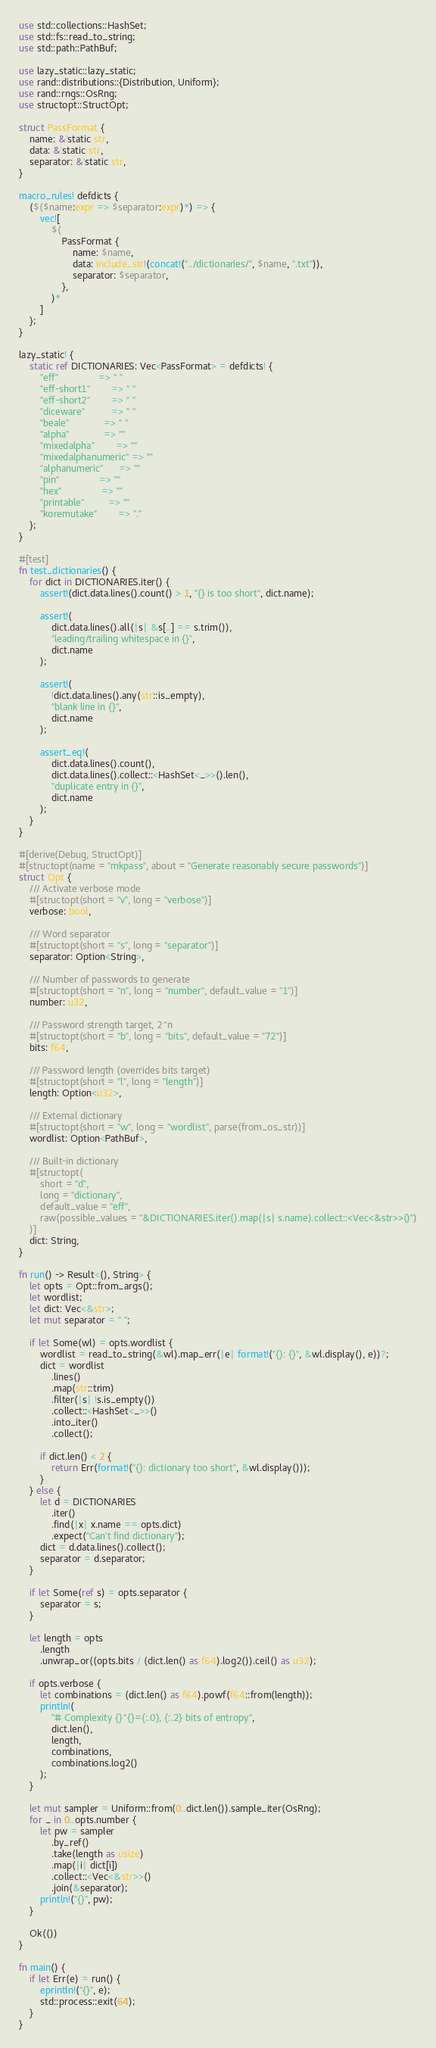<code> <loc_0><loc_0><loc_500><loc_500><_Rust_>use std::collections::HashSet;
use std::fs::read_to_string;
use std::path::PathBuf;

use lazy_static::lazy_static;
use rand::distributions::{Distribution, Uniform};
use rand::rngs::OsRng;
use structopt::StructOpt;

struct PassFormat {
    name: &'static str,
    data: &'static str,
    separator: &'static str,
}

macro_rules! defdicts {
    ($($name:expr => $separator:expr)*) => {
        vec![
            $(
                PassFormat {
                    name: $name,
                    data: include_str!(concat!("../dictionaries/", $name, ".txt")),
                    separator: $separator,
                },
            )*
        ]
    };
}

lazy_static! {
    static ref DICTIONARIES: Vec<PassFormat> = defdicts! {
        "eff"               => " "
        "eff-short1"        => " "
        "eff-short2"        => " "
        "diceware"          => " "
        "beale"             => " "
        "alpha"             => ""
        "mixedalpha"        => ""
        "mixedalphanumeric" => ""
        "alphanumeric"      => ""
        "pin"               => ""
        "hex"               => ""
        "printable"         => ""
        "koremutake"        => "."
    };
}

#[test]
fn test_dictionaries() {
    for dict in DICTIONARIES.iter() {
        assert!(dict.data.lines().count() > 1, "{} is too short", dict.name);

        assert!(
            dict.data.lines().all(|s| &s[..] == s.trim()),
            "leading/trailing whitespace in {}",
            dict.name
        );

        assert!(
            !dict.data.lines().any(str::is_empty),
            "blank line in {}",
            dict.name
        );

        assert_eq!(
            dict.data.lines().count(),
            dict.data.lines().collect::<HashSet<_>>().len(),
            "duplicate entry in {}",
            dict.name
        );
    }
}

#[derive(Debug, StructOpt)]
#[structopt(name = "mkpass", about = "Generate reasonably secure passwords")]
struct Opt {
    /// Activate verbose mode
    #[structopt(short = "v", long = "verbose")]
    verbose: bool,

    /// Word separator
    #[structopt(short = "s", long = "separator")]
    separator: Option<String>,

    /// Number of passwords to generate
    #[structopt(short = "n", long = "number", default_value = "1")]
    number: u32,

    /// Password strength target, 2^n
    #[structopt(short = "b", long = "bits", default_value = "72")]
    bits: f64,

    /// Password length (overrides bits target)
    #[structopt(short = "l", long = "length")]
    length: Option<u32>,

    /// External dictionary
    #[structopt(short = "w", long = "wordlist", parse(from_os_str))]
    wordlist: Option<PathBuf>,

    /// Built-in dictionary
    #[structopt(
        short = "d",
        long = "dictionary",
        default_value = "eff",
        raw(possible_values = "&DICTIONARIES.iter().map(|s| s.name).collect::<Vec<&str>>()")
    )]
    dict: String,
}

fn run() -> Result<(), String> {
    let opts = Opt::from_args();
    let wordlist;
    let dict: Vec<&str>;
    let mut separator = " ";

    if let Some(wl) = opts.wordlist {
        wordlist = read_to_string(&wl).map_err(|e| format!("{}: {}", &wl.display(), e))?;
        dict = wordlist
            .lines()
            .map(str::trim)
            .filter(|s| !s.is_empty())
            .collect::<HashSet<_>>()
            .into_iter()
            .collect();

        if dict.len() < 2 {
            return Err(format!("{}: dictionary too short", &wl.display()));
        }
    } else {
        let d = DICTIONARIES
            .iter()
            .find(|x| x.name == opts.dict)
            .expect("Can't find dictionary");
        dict = d.data.lines().collect();
        separator = d.separator;
    }

    if let Some(ref s) = opts.separator {
        separator = s;
    }

    let length = opts
        .length
        .unwrap_or((opts.bits / (dict.len() as f64).log2()).ceil() as u32);

    if opts.verbose {
        let combinations = (dict.len() as f64).powf(f64::from(length));
        println!(
            "# Complexity {}^{}={:.0}, {:.2} bits of entropy",
            dict.len(),
            length,
            combinations,
            combinations.log2()
        );
    }

    let mut sampler = Uniform::from(0..dict.len()).sample_iter(OsRng);
    for _ in 0..opts.number {
        let pw = sampler
            .by_ref()
            .take(length as usize)
            .map(|i| dict[i])
            .collect::<Vec<&str>>()
            .join(&separator);
        println!("{}", pw);
    }

    Ok(())
}

fn main() {
    if let Err(e) = run() {
        eprintln!("{}", e);
        std::process::exit(64);
    }
}
</code> 